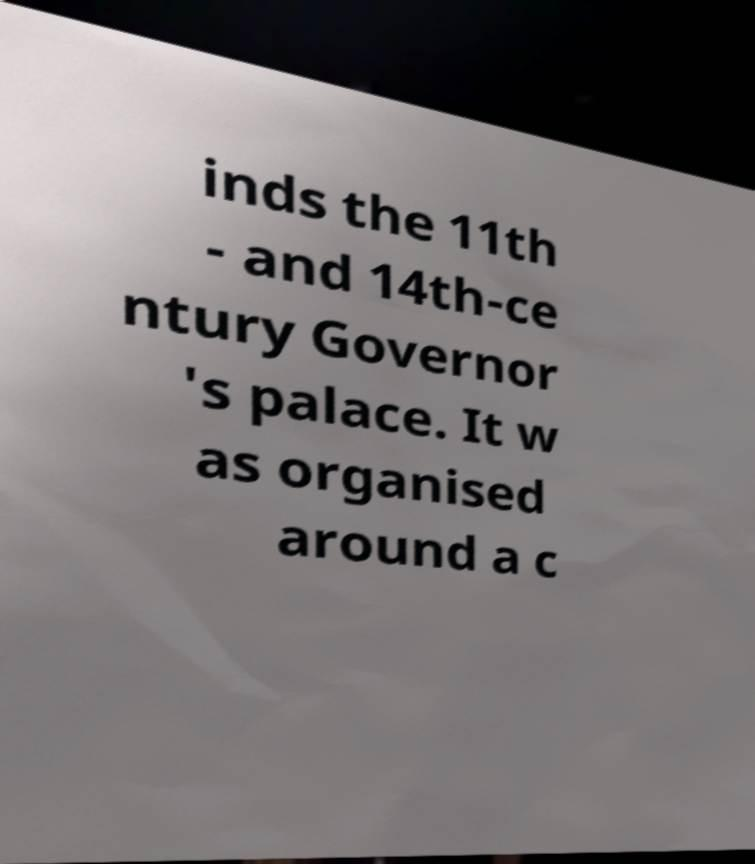Please read and relay the text visible in this image. What does it say? inds the 11th - and 14th-ce ntury Governor 's palace. It w as organised around a c 